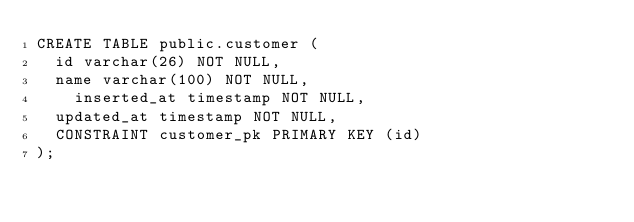<code> <loc_0><loc_0><loc_500><loc_500><_SQL_>CREATE TABLE public.customer (
	id varchar(26) NOT NULL,
	name varchar(100) NOT NULL,
    inserted_at timestamp NOT NULL,
	updated_at timestamp NOT NULL,
	CONSTRAINT customer_pk PRIMARY KEY (id)
);
</code> 